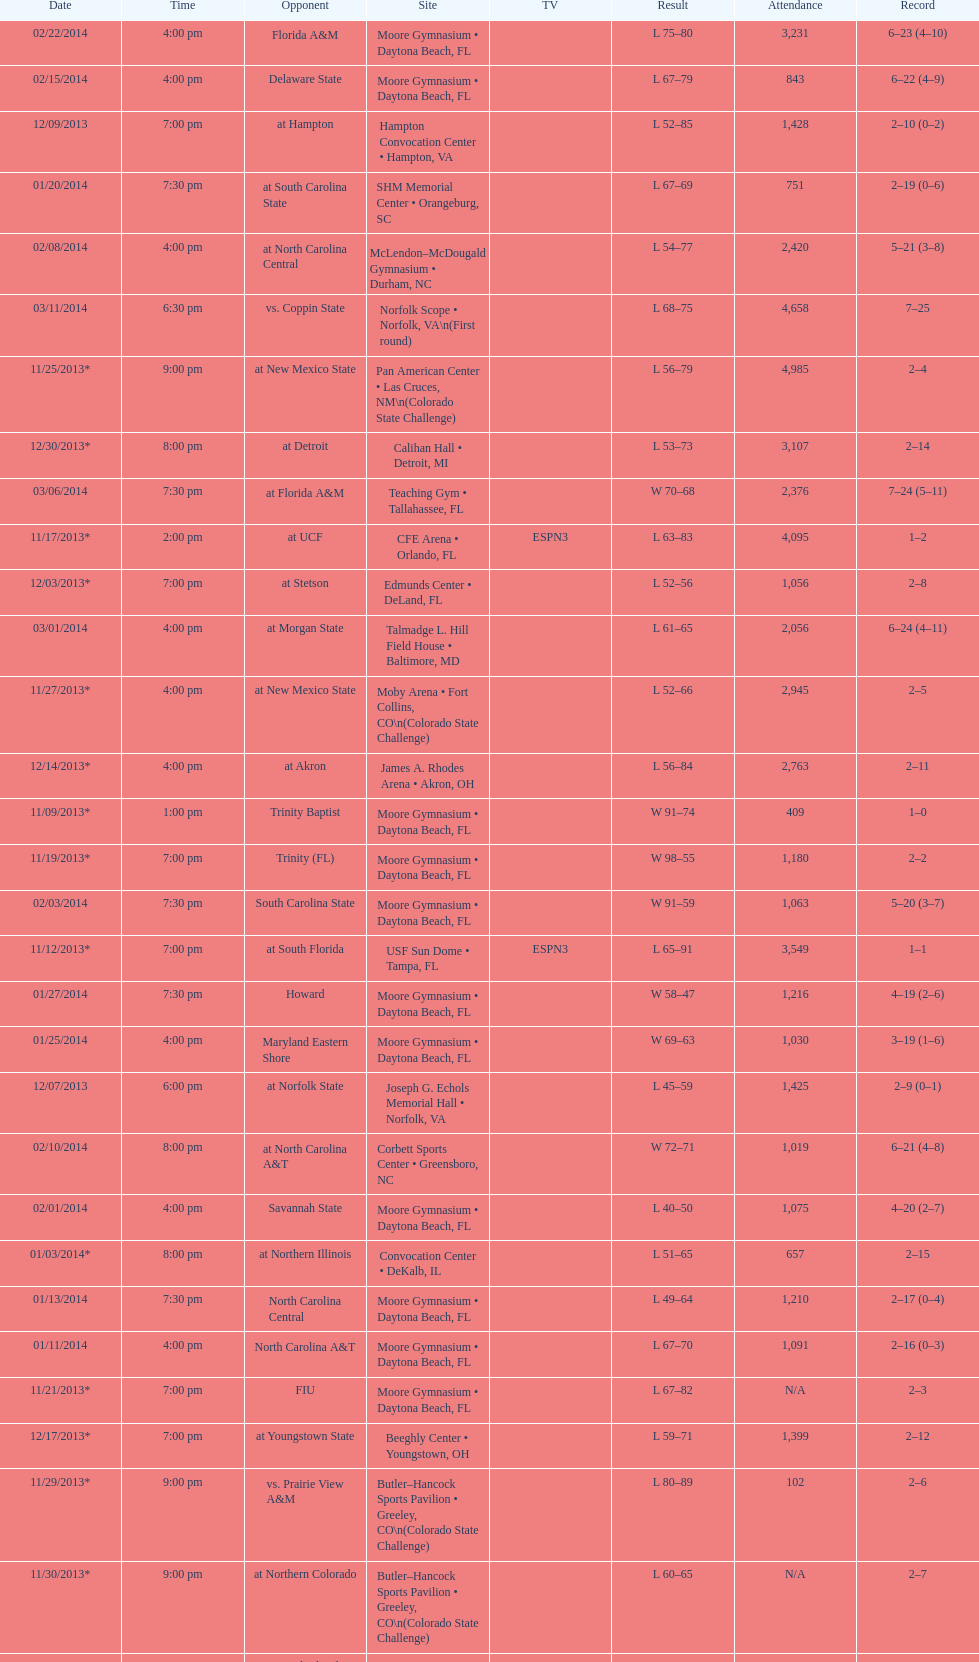How many games had more than 1,500 in attendance? 12. 